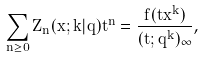Convert formula to latex. <formula><loc_0><loc_0><loc_500><loc_500>\sum _ { n \geq 0 } Z _ { n } ( x ; k | q ) t ^ { n } = \frac { f ( t x ^ { k } ) } { ( t ; q ^ { k } ) _ { \infty } } ,</formula> 